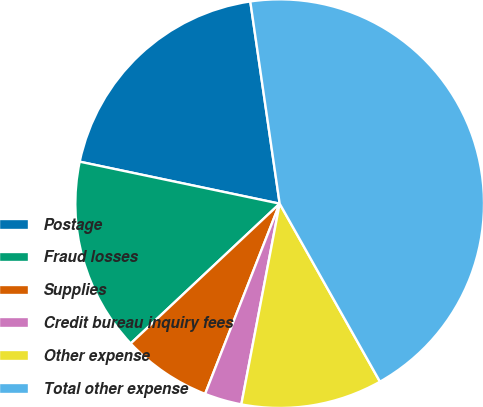Convert chart to OTSL. <chart><loc_0><loc_0><loc_500><loc_500><pie_chart><fcel>Postage<fcel>Fraud losses<fcel>Supplies<fcel>Credit bureau inquiry fees<fcel>Other expense<fcel>Total other expense<nl><fcel>19.41%<fcel>15.29%<fcel>7.06%<fcel>2.94%<fcel>11.17%<fcel>44.13%<nl></chart> 